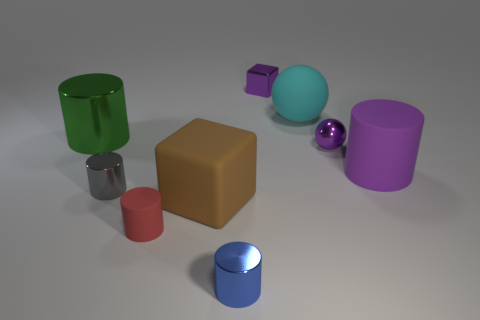How many large objects are blue objects or gray cylinders?
Your response must be concise. 0. Are there more big spheres than red shiny cubes?
Make the answer very short. Yes. How many cubes are right of the cylinder that is right of the sphere in front of the large cyan rubber sphere?
Offer a very short reply. 0. The brown object is what shape?
Your answer should be very brief. Cube. How many other things are there of the same material as the large green thing?
Ensure brevity in your answer.  4. Do the red cylinder and the cyan matte object have the same size?
Offer a very short reply. No. There is a thing in front of the small red rubber thing; what is its shape?
Your response must be concise. Cylinder. There is a large cylinder left of the metallic cylinder in front of the gray metal cylinder; what is its color?
Your answer should be very brief. Green. There is a purple metal object behind the small shiny sphere; does it have the same shape as the blue metal thing that is on the left side of the purple ball?
Offer a very short reply. No. There is a gray object that is the same size as the red rubber cylinder; what shape is it?
Provide a succinct answer. Cylinder. 